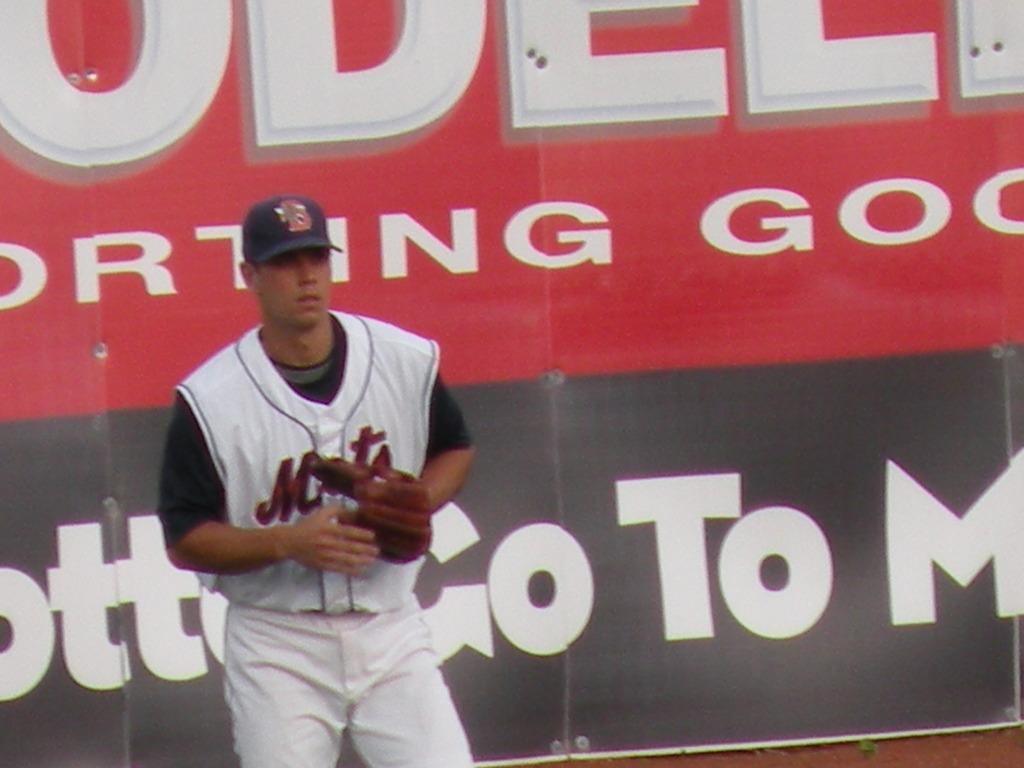Who is present in the image? There is a man in the image. What is the man wearing? The man is wearing a white dress and a cap. What can be seen behind the man? There is a banner behind the man. What type of hospital equipment can be seen in the image? There is no hospital equipment present in the image. What role does the man's mother play in the image? The man's mother is not present in the image, so her role cannot be determined. 